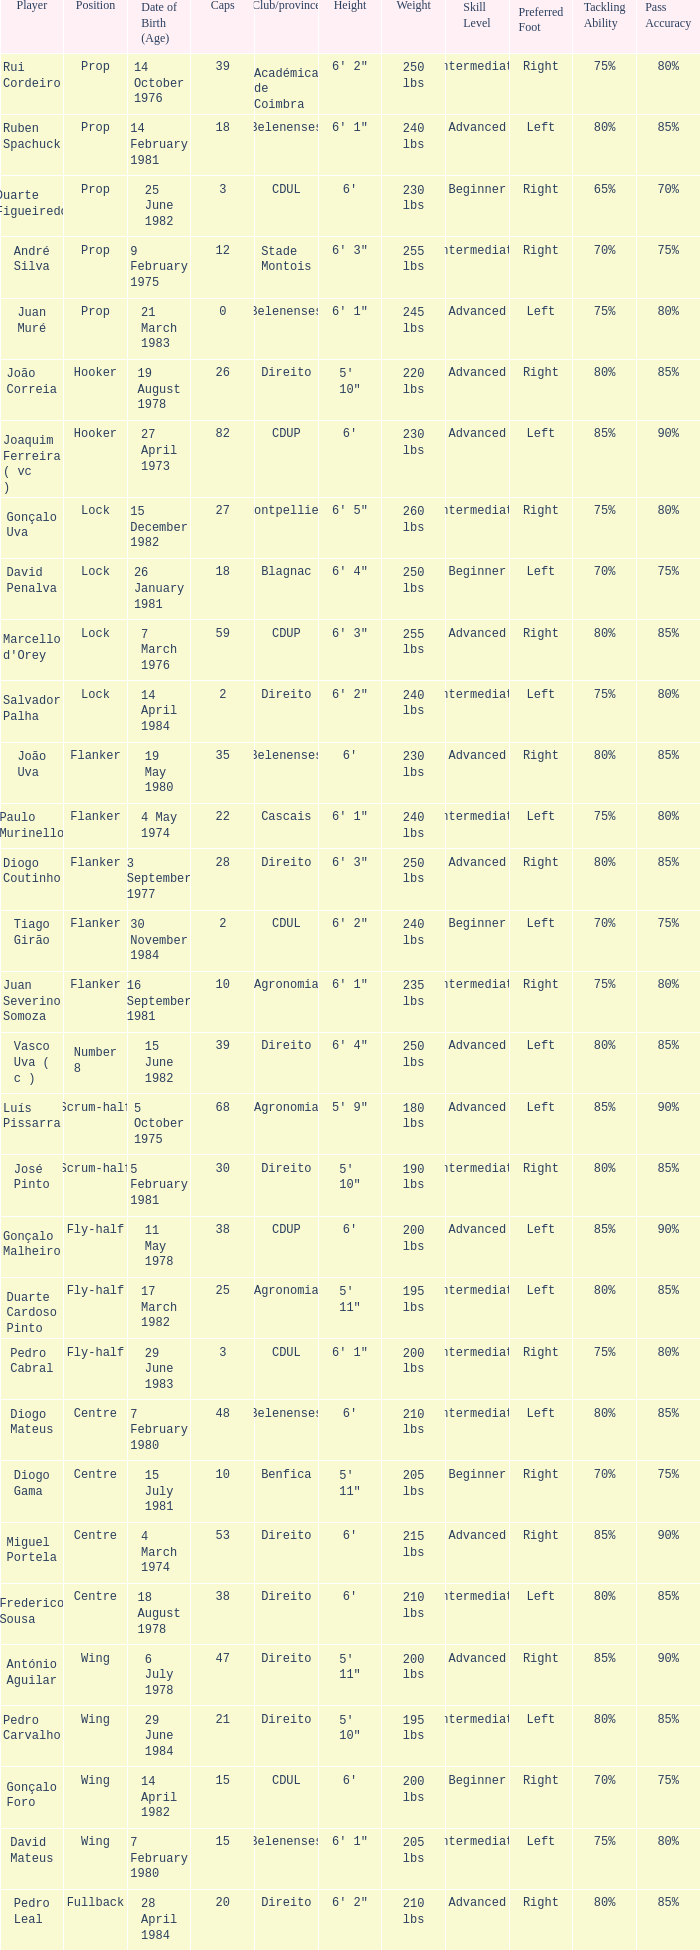Which Club/province has a Player of david penalva? Blagnac. 